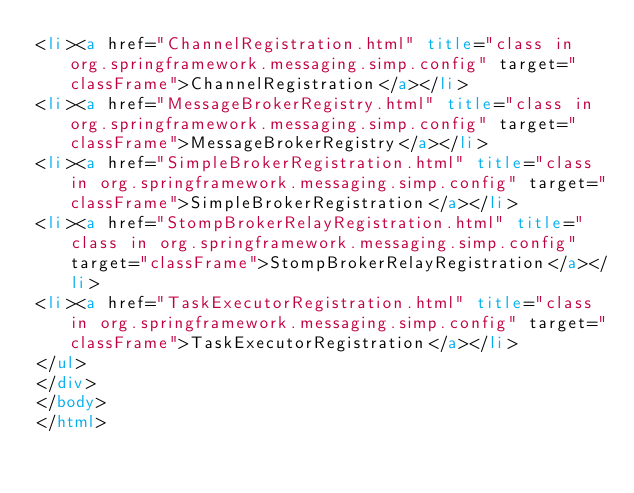Convert code to text. <code><loc_0><loc_0><loc_500><loc_500><_HTML_><li><a href="ChannelRegistration.html" title="class in org.springframework.messaging.simp.config" target="classFrame">ChannelRegistration</a></li>
<li><a href="MessageBrokerRegistry.html" title="class in org.springframework.messaging.simp.config" target="classFrame">MessageBrokerRegistry</a></li>
<li><a href="SimpleBrokerRegistration.html" title="class in org.springframework.messaging.simp.config" target="classFrame">SimpleBrokerRegistration</a></li>
<li><a href="StompBrokerRelayRegistration.html" title="class in org.springframework.messaging.simp.config" target="classFrame">StompBrokerRelayRegistration</a></li>
<li><a href="TaskExecutorRegistration.html" title="class in org.springframework.messaging.simp.config" target="classFrame">TaskExecutorRegistration</a></li>
</ul>
</div>
</body>
</html>
</code> 